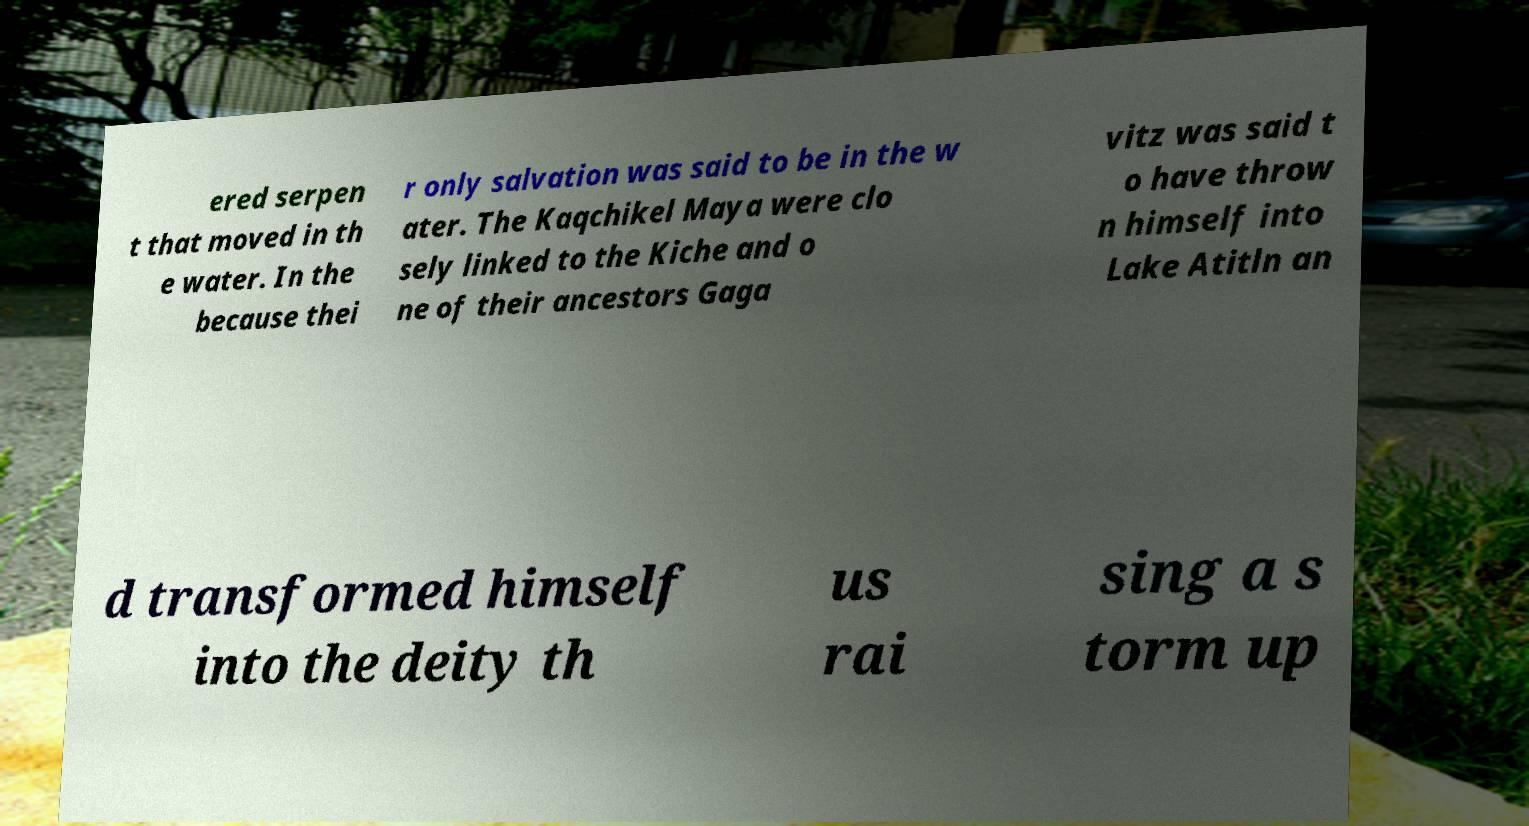Can you read and provide the text displayed in the image?This photo seems to have some interesting text. Can you extract and type it out for me? ered serpen t that moved in th e water. In the because thei r only salvation was said to be in the w ater. The Kaqchikel Maya were clo sely linked to the Kiche and o ne of their ancestors Gaga vitz was said t o have throw n himself into Lake Atitln an d transformed himself into the deity th us rai sing a s torm up 